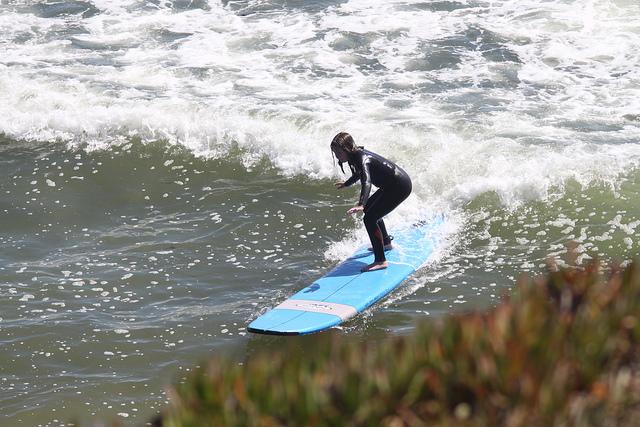What color is the surfboard?
Keep it brief. Blue. Is the surfer a female?
Quick response, please. Yes. What gender is the person?
Give a very brief answer. Female. What is under the person's feet?
Be succinct. Surfboard. Is she wearing a helmet?
Write a very short answer. No. 